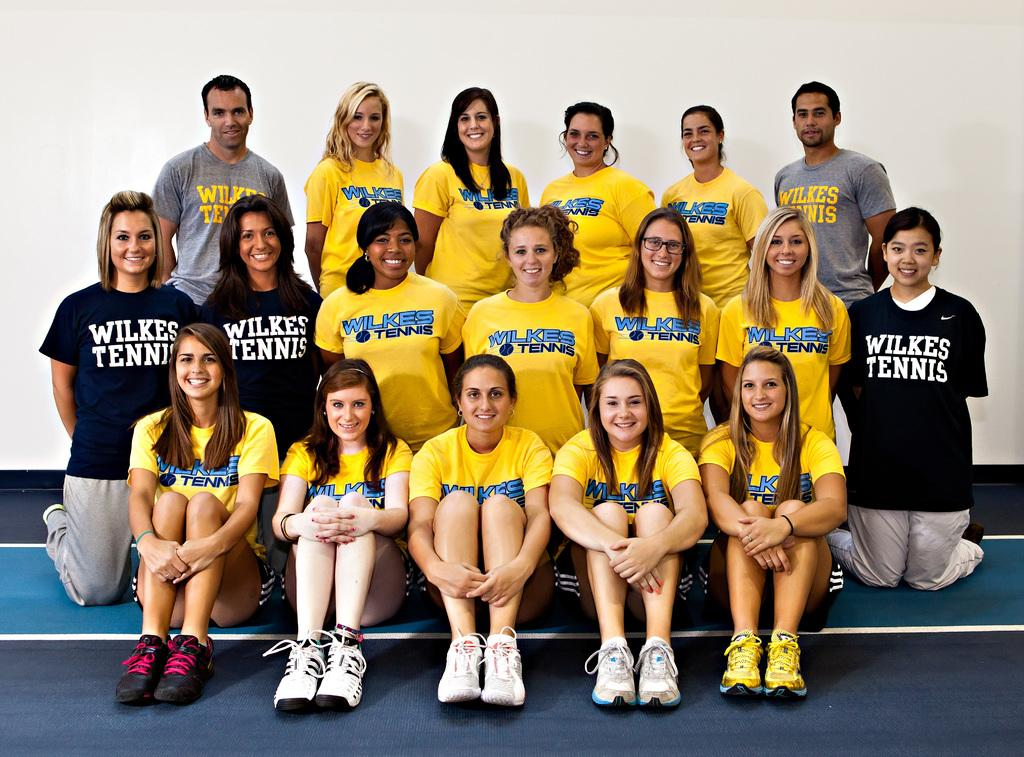<image>
Render a clear and concise summary of the photo. Girls pose together in Wilkes Tennis shirts and sneakers. 